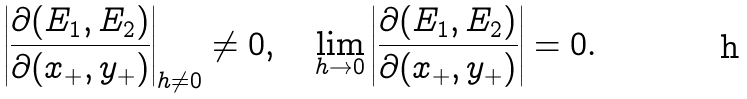<formula> <loc_0><loc_0><loc_500><loc_500>\left | \frac { \partial ( E _ { 1 } , E _ { 2 } ) } { \partial ( x _ { + } , y _ { + } ) } \right | _ { h \neq 0 } \neq 0 , \quad \lim _ { h \to 0 } \left | \frac { \partial ( E _ { 1 } , E _ { 2 } ) } { \partial ( x _ { + } , y _ { + } ) } \right | = 0 .</formula> 